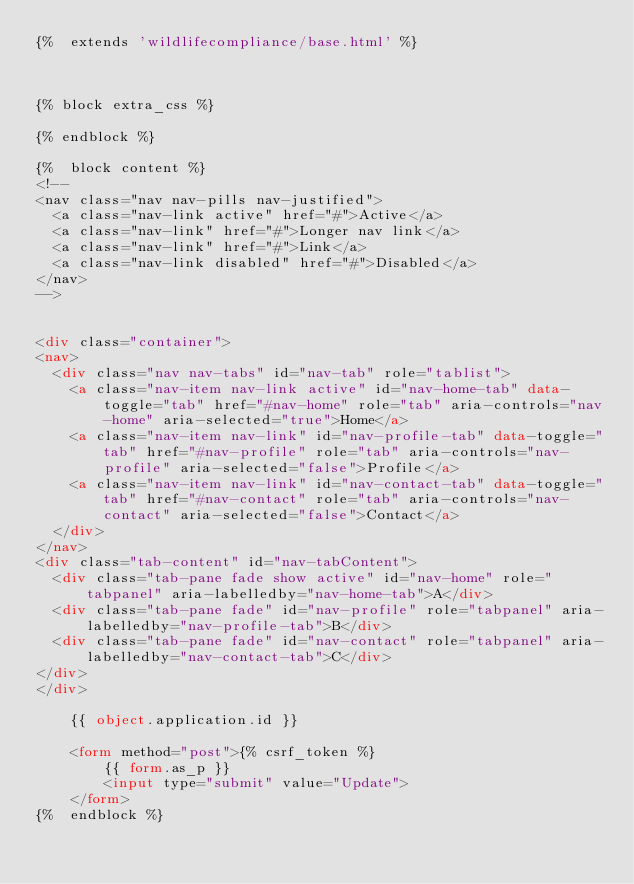Convert code to text. <code><loc_0><loc_0><loc_500><loc_500><_HTML_>{%  extends 'wildlifecompliance/base.html' %}



{% block extra_css %}

{% endblock %}

{%  block content %}
<!--
<nav class="nav nav-pills nav-justified">
  <a class="nav-link active" href="#">Active</a>
  <a class="nav-link" href="#">Longer nav link</a>
  <a class="nav-link" href="#">Link</a>
  <a class="nav-link disabled" href="#">Disabled</a>
</nav>
-->


<div class="container">
<nav>
  <div class="nav nav-tabs" id="nav-tab" role="tablist">
    <a class="nav-item nav-link active" id="nav-home-tab" data-toggle="tab" href="#nav-home" role="tab" aria-controls="nav-home" aria-selected="true">Home</a>
    <a class="nav-item nav-link" id="nav-profile-tab" data-toggle="tab" href="#nav-profile" role="tab" aria-controls="nav-profile" aria-selected="false">Profile</a>
    <a class="nav-item nav-link" id="nav-contact-tab" data-toggle="tab" href="#nav-contact" role="tab" aria-controls="nav-contact" aria-selected="false">Contact</a>
  </div>
</nav>
<div class="tab-content" id="nav-tabContent">
  <div class="tab-pane fade show active" id="nav-home" role="tabpanel" aria-labelledby="nav-home-tab">A</div>
  <div class="tab-pane fade" id="nav-profile" role="tabpanel" aria-labelledby="nav-profile-tab">B</div>
  <div class="tab-pane fade" id="nav-contact" role="tabpanel" aria-labelledby="nav-contact-tab">C</div>
</div>
</div>

    {{ object.application.id }}

    <form method="post">{% csrf_token %}
        {{ form.as_p }}
        <input type="submit" value="Update">
    </form>
{%  endblock %}

</code> 